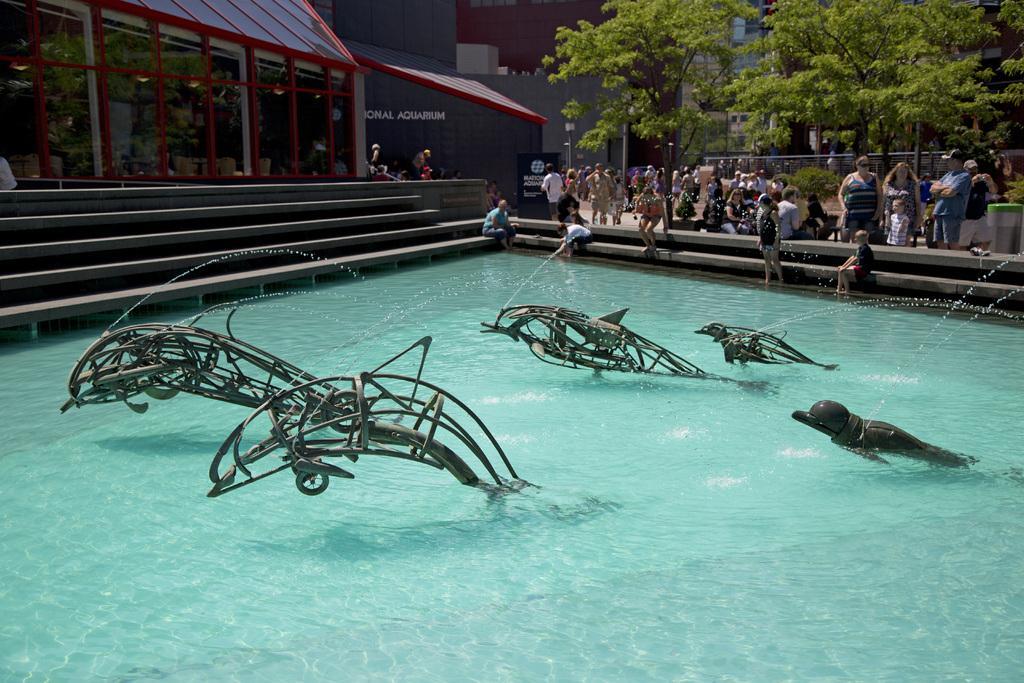How would you summarize this image in a sentence or two? This image consists of pool in the middle. There are some persons in the middle. There are trees at the top. 